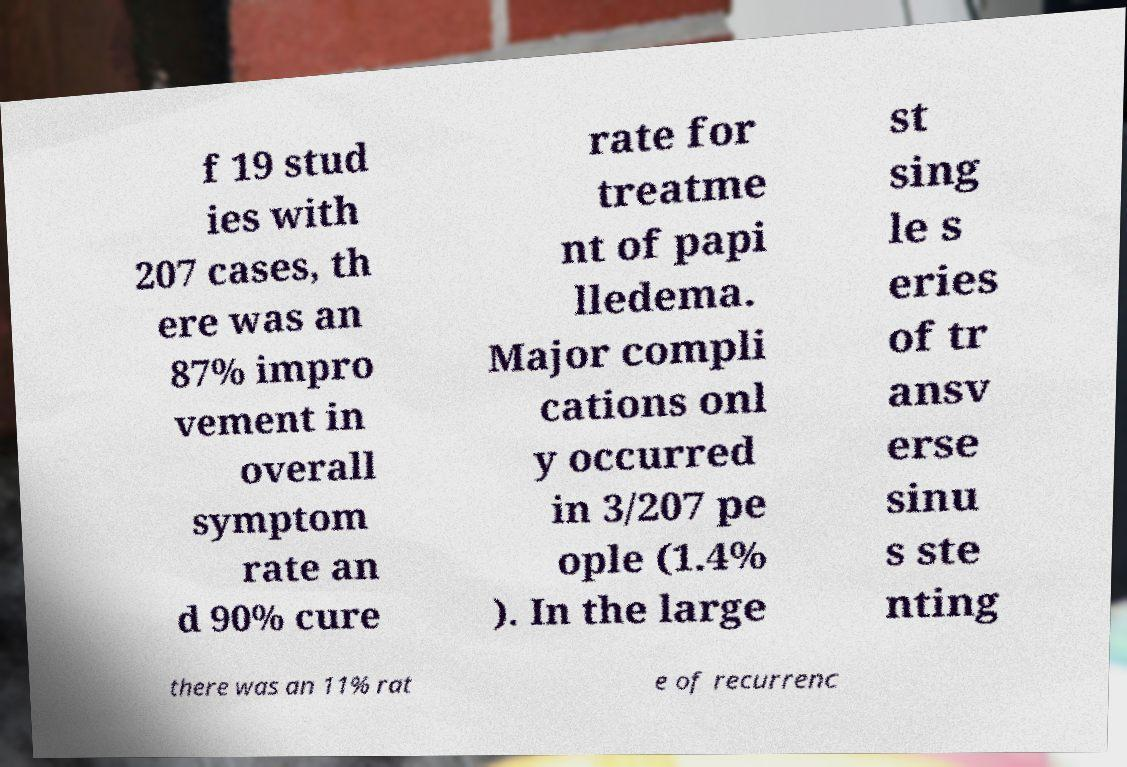I need the written content from this picture converted into text. Can you do that? f 19 stud ies with 207 cases, th ere was an 87% impro vement in overall symptom rate an d 90% cure rate for treatme nt of papi lledema. Major compli cations onl y occurred in 3/207 pe ople (1.4% ). In the large st sing le s eries of tr ansv erse sinu s ste nting there was an 11% rat e of recurrenc 